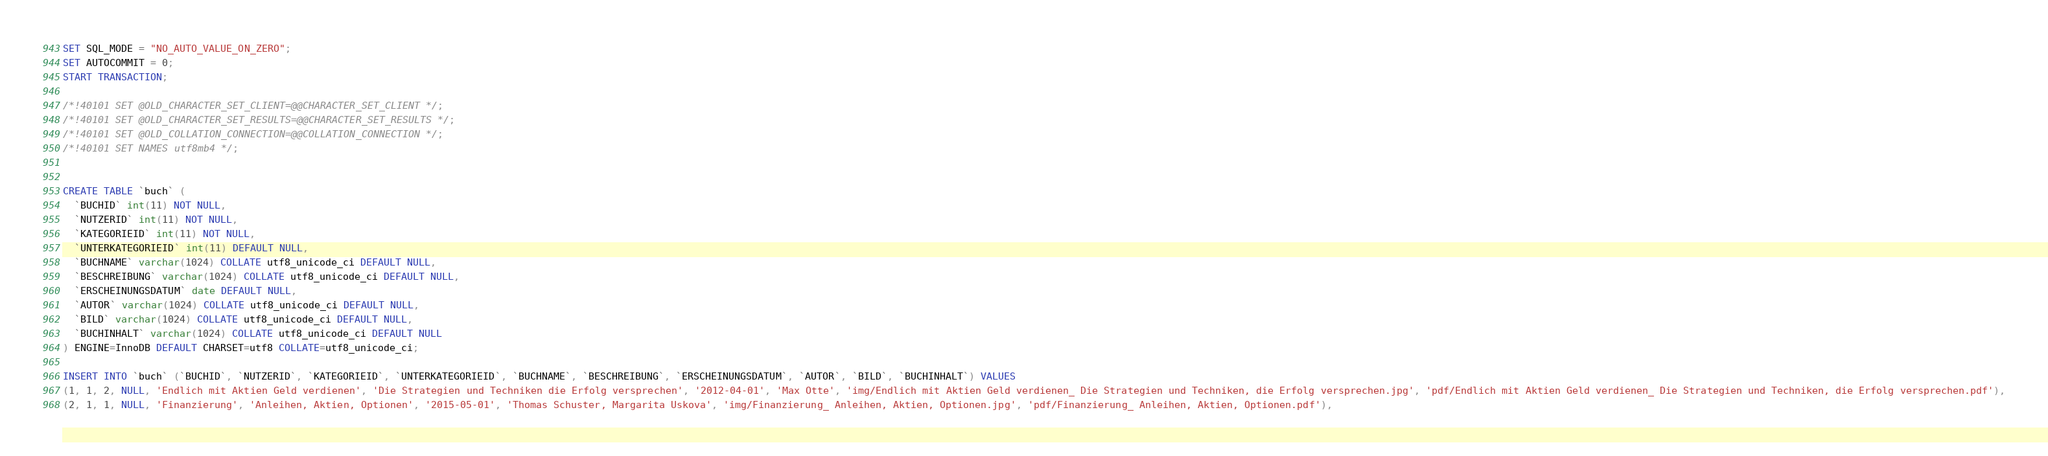<code> <loc_0><loc_0><loc_500><loc_500><_SQL_>SET SQL_MODE = "NO_AUTO_VALUE_ON_ZERO";
SET AUTOCOMMIT = 0;
START TRANSACTION;

/*!40101 SET @OLD_CHARACTER_SET_CLIENT=@@CHARACTER_SET_CLIENT */;
/*!40101 SET @OLD_CHARACTER_SET_RESULTS=@@CHARACTER_SET_RESULTS */;
/*!40101 SET @OLD_COLLATION_CONNECTION=@@COLLATION_CONNECTION */;
/*!40101 SET NAMES utf8mb4 */;


CREATE TABLE `buch` (
  `BUCHID` int(11) NOT NULL,
  `NUTZERID` int(11) NOT NULL,
  `KATEGORIEID` int(11) NOT NULL,
  `UNTERKATEGORIEID` int(11) DEFAULT NULL,
  `BUCHNAME` varchar(1024) COLLATE utf8_unicode_ci DEFAULT NULL,
  `BESCHREIBUNG` varchar(1024) COLLATE utf8_unicode_ci DEFAULT NULL,
  `ERSCHEINUNGSDATUM` date DEFAULT NULL,
  `AUTOR` varchar(1024) COLLATE utf8_unicode_ci DEFAULT NULL,
  `BILD` varchar(1024) COLLATE utf8_unicode_ci DEFAULT NULL,
  `BUCHINHALT` varchar(1024) COLLATE utf8_unicode_ci DEFAULT NULL
) ENGINE=InnoDB DEFAULT CHARSET=utf8 COLLATE=utf8_unicode_ci;

INSERT INTO `buch` (`BUCHID`, `NUTZERID`, `KATEGORIEID`, `UNTERKATEGORIEID`, `BUCHNAME`, `BESCHREIBUNG`, `ERSCHEINUNGSDATUM`, `AUTOR`, `BILD`, `BUCHINHALT`) VALUES
(1, 1, 2, NULL, 'Endlich mit Aktien Geld verdienen', 'Die Strategien und Techniken die Erfolg versprechen', '2012-04-01', 'Max Otte', 'img/Endlich mit Aktien Geld verdienen_ Die Strategien und Techniken, die Erfolg versprechen.jpg', 'pdf/Endlich mit Aktien Geld verdienen_ Die Strategien und Techniken, die Erfolg versprechen.pdf'),
(2, 1, 1, NULL, 'Finanzierung', 'Anleihen, Aktien, Optionen', '2015-05-01', 'Thomas Schuster, Margarita Uskova', 'img/Finanzierung_ Anleihen, Aktien, Optionen.jpg', 'pdf/Finanzierung_ Anleihen, Aktien, Optionen.pdf'),</code> 